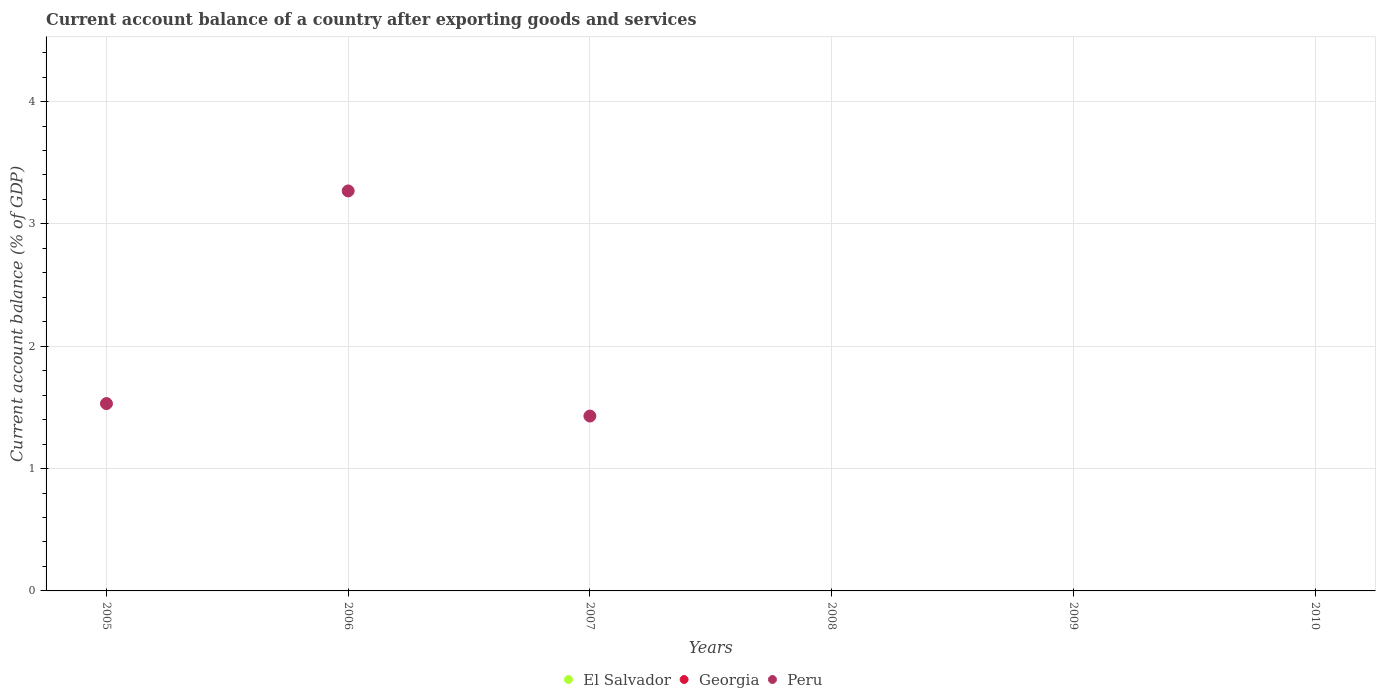How many different coloured dotlines are there?
Your response must be concise. 1. What is the account balance in Georgia in 2010?
Provide a short and direct response. 0. Across all years, what is the maximum account balance in Peru?
Give a very brief answer. 3.27. In which year was the account balance in Peru maximum?
Your response must be concise. 2006. What is the total account balance in Georgia in the graph?
Offer a very short reply. 0. What is the difference between the account balance in Peru in 2005 and that in 2007?
Offer a very short reply. 0.1. What is the difference between the account balance in El Salvador in 2006 and the account balance in Georgia in 2009?
Ensure brevity in your answer.  0. What is the average account balance in Peru per year?
Provide a succinct answer. 1.04. What is the difference between the highest and the second highest account balance in Peru?
Offer a terse response. 1.74. What is the difference between the highest and the lowest account balance in Peru?
Make the answer very short. 3.27. In how many years, is the account balance in Peru greater than the average account balance in Peru taken over all years?
Provide a short and direct response. 3. Is the sum of the account balance in Peru in 2005 and 2007 greater than the maximum account balance in Georgia across all years?
Give a very brief answer. Yes. How many years are there in the graph?
Offer a very short reply. 6. Are the values on the major ticks of Y-axis written in scientific E-notation?
Give a very brief answer. No. Where does the legend appear in the graph?
Provide a short and direct response. Bottom center. What is the title of the graph?
Keep it short and to the point. Current account balance of a country after exporting goods and services. What is the label or title of the X-axis?
Your response must be concise. Years. What is the label or title of the Y-axis?
Ensure brevity in your answer.  Current account balance (% of GDP). What is the Current account balance (% of GDP) of El Salvador in 2005?
Ensure brevity in your answer.  0. What is the Current account balance (% of GDP) of Georgia in 2005?
Make the answer very short. 0. What is the Current account balance (% of GDP) in Peru in 2005?
Keep it short and to the point. 1.53. What is the Current account balance (% of GDP) in El Salvador in 2006?
Provide a short and direct response. 0. What is the Current account balance (% of GDP) of Peru in 2006?
Ensure brevity in your answer.  3.27. What is the Current account balance (% of GDP) of Georgia in 2007?
Your answer should be compact. 0. What is the Current account balance (% of GDP) in Peru in 2007?
Your response must be concise. 1.43. What is the Current account balance (% of GDP) of Georgia in 2009?
Give a very brief answer. 0. What is the Current account balance (% of GDP) of Peru in 2009?
Provide a succinct answer. 0. Across all years, what is the maximum Current account balance (% of GDP) in Peru?
Make the answer very short. 3.27. What is the total Current account balance (% of GDP) in El Salvador in the graph?
Keep it short and to the point. 0. What is the total Current account balance (% of GDP) in Peru in the graph?
Give a very brief answer. 6.23. What is the difference between the Current account balance (% of GDP) in Peru in 2005 and that in 2006?
Your answer should be compact. -1.74. What is the difference between the Current account balance (% of GDP) of Peru in 2005 and that in 2007?
Offer a very short reply. 0.1. What is the difference between the Current account balance (% of GDP) in Peru in 2006 and that in 2007?
Your response must be concise. 1.84. What is the average Current account balance (% of GDP) of El Salvador per year?
Offer a very short reply. 0. What is the average Current account balance (% of GDP) in Peru per year?
Keep it short and to the point. 1.04. What is the ratio of the Current account balance (% of GDP) in Peru in 2005 to that in 2006?
Ensure brevity in your answer.  0.47. What is the ratio of the Current account balance (% of GDP) of Peru in 2005 to that in 2007?
Your answer should be compact. 1.07. What is the ratio of the Current account balance (% of GDP) of Peru in 2006 to that in 2007?
Give a very brief answer. 2.29. What is the difference between the highest and the second highest Current account balance (% of GDP) in Peru?
Give a very brief answer. 1.74. What is the difference between the highest and the lowest Current account balance (% of GDP) in Peru?
Your response must be concise. 3.27. 